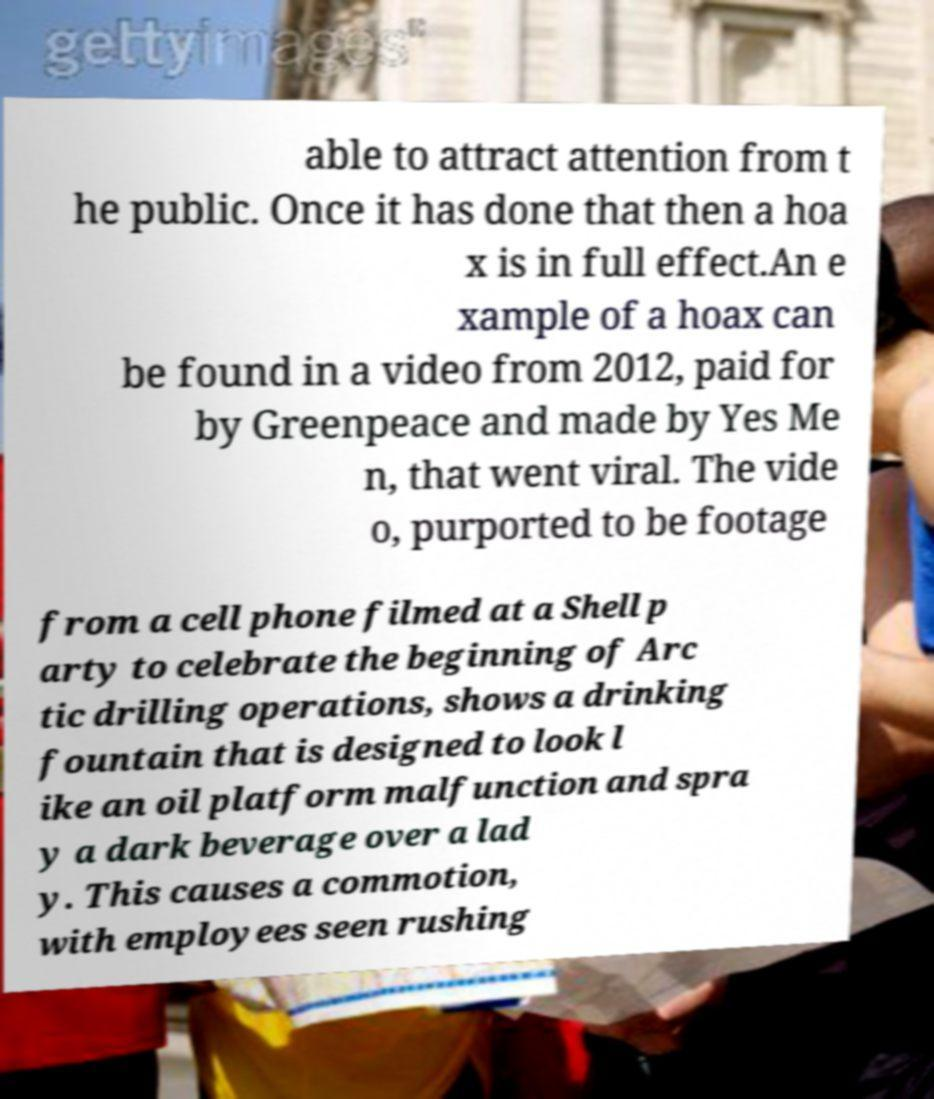What messages or text are displayed in this image? I need them in a readable, typed format. able to attract attention from t he public. Once it has done that then a hoa x is in full effect.An e xample of a hoax can be found in a video from 2012, paid for by Greenpeace and made by Yes Me n, that went viral. The vide o, purported to be footage from a cell phone filmed at a Shell p arty to celebrate the beginning of Arc tic drilling operations, shows a drinking fountain that is designed to look l ike an oil platform malfunction and spra y a dark beverage over a lad y. This causes a commotion, with employees seen rushing 